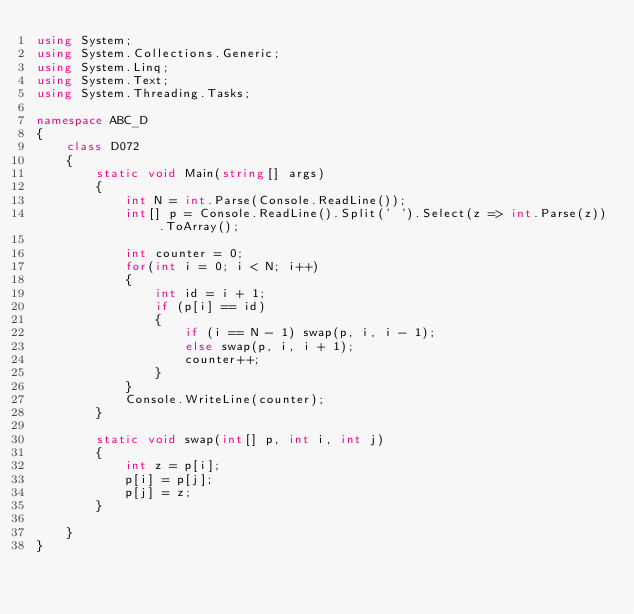<code> <loc_0><loc_0><loc_500><loc_500><_C#_>using System;
using System.Collections.Generic;
using System.Linq;
using System.Text;
using System.Threading.Tasks;

namespace ABC_D
{
    class D072
    {
        static void Main(string[] args)
        {
            int N = int.Parse(Console.ReadLine());
            int[] p = Console.ReadLine().Split(' ').Select(z => int.Parse(z)).ToArray();

            int counter = 0;
            for(int i = 0; i < N; i++)
            {
                int id = i + 1;
                if (p[i] == id)
                {
                    if (i == N - 1) swap(p, i, i - 1);
                    else swap(p, i, i + 1);
                    counter++;
                }
            }
            Console.WriteLine(counter);
        }

        static void swap(int[] p, int i, int j)
        {
            int z = p[i];
            p[i] = p[j];
            p[j] = z;
        }

    }
}
</code> 